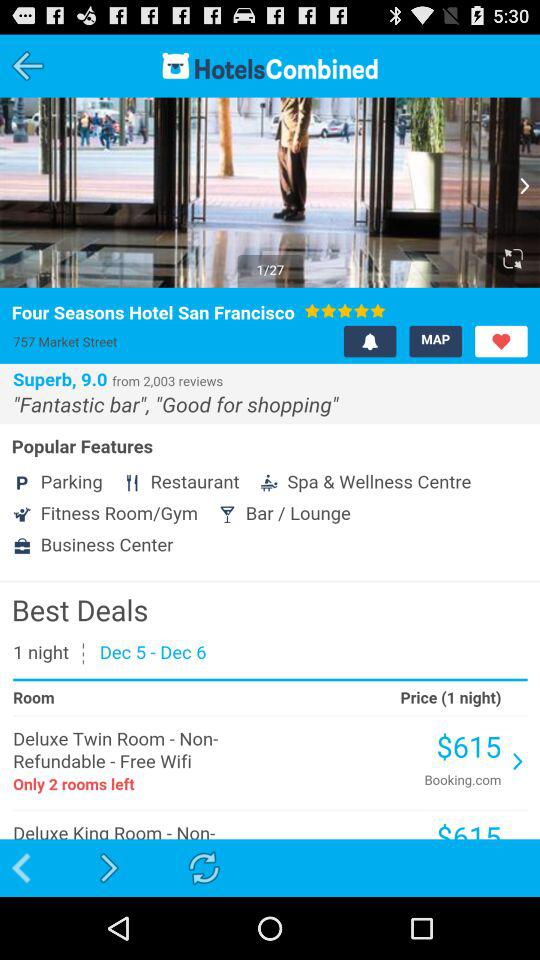Is Wifi free or paid? The Wifi is free. 